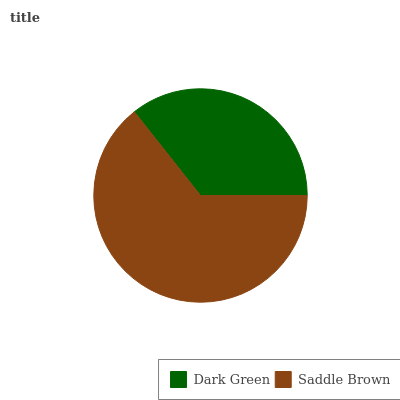Is Dark Green the minimum?
Answer yes or no. Yes. Is Saddle Brown the maximum?
Answer yes or no. Yes. Is Saddle Brown the minimum?
Answer yes or no. No. Is Saddle Brown greater than Dark Green?
Answer yes or no. Yes. Is Dark Green less than Saddle Brown?
Answer yes or no. Yes. Is Dark Green greater than Saddle Brown?
Answer yes or no. No. Is Saddle Brown less than Dark Green?
Answer yes or no. No. Is Saddle Brown the high median?
Answer yes or no. Yes. Is Dark Green the low median?
Answer yes or no. Yes. Is Dark Green the high median?
Answer yes or no. No. Is Saddle Brown the low median?
Answer yes or no. No. 